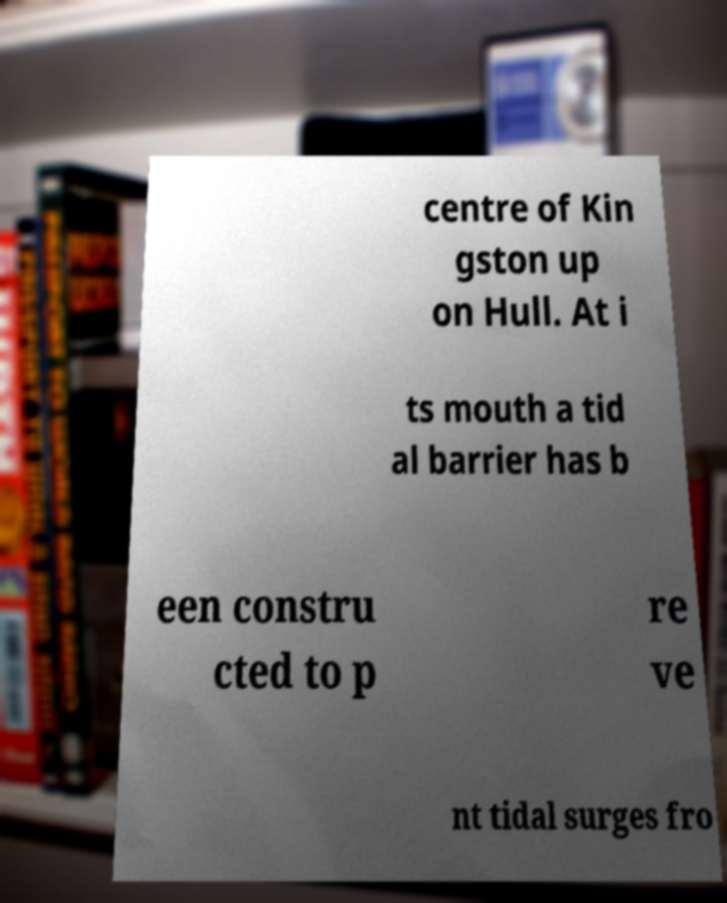Can you read and provide the text displayed in the image?This photo seems to have some interesting text. Can you extract and type it out for me? centre of Kin gston up on Hull. At i ts mouth a tid al barrier has b een constru cted to p re ve nt tidal surges fro 